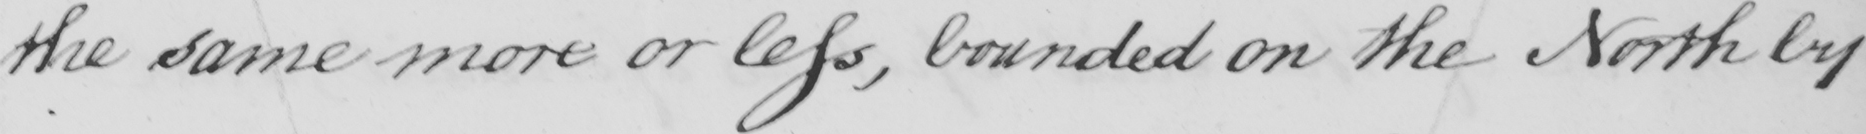Please transcribe the handwritten text in this image. the same more or less , bounded on the North by 